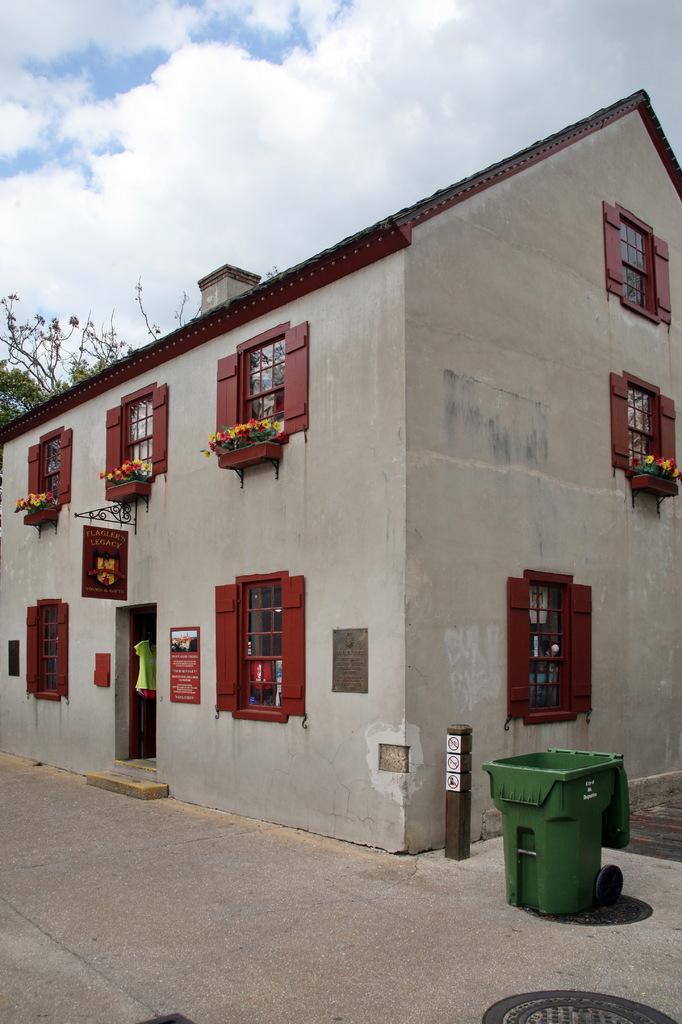Please provide a concise description of this image. In this image there is a building with glass windows and a door, beside the building there is a trash can, on the other side of the building there is a tree. 